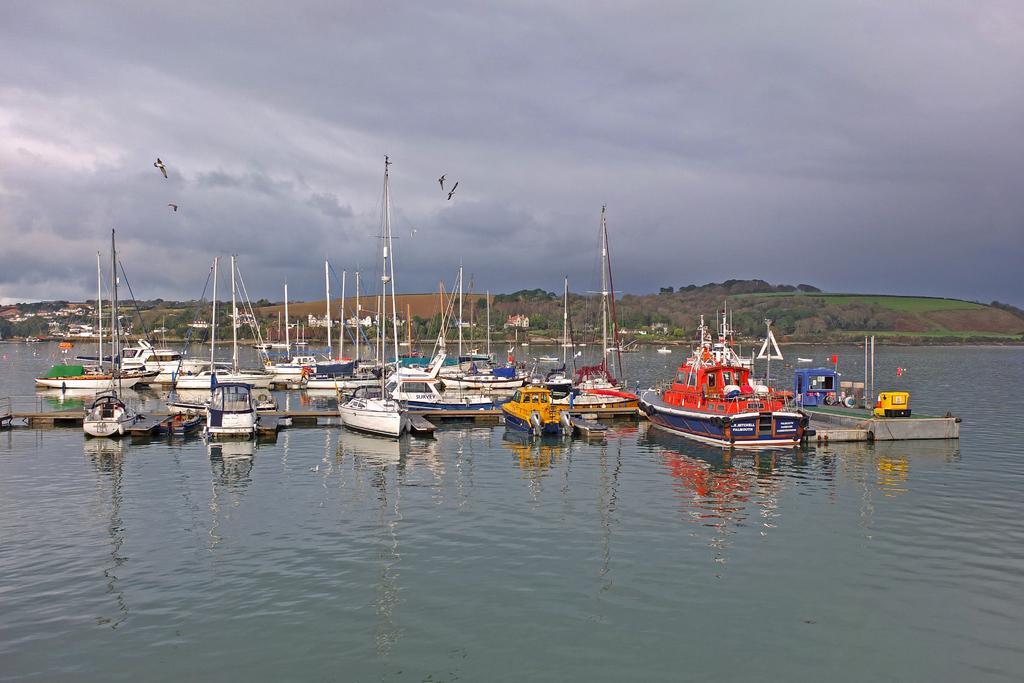In one or two sentences, can you explain what this image depicts? In this image we can see the boats on the surface of the water. In the background we can see the trees and also the cloudy sky. 